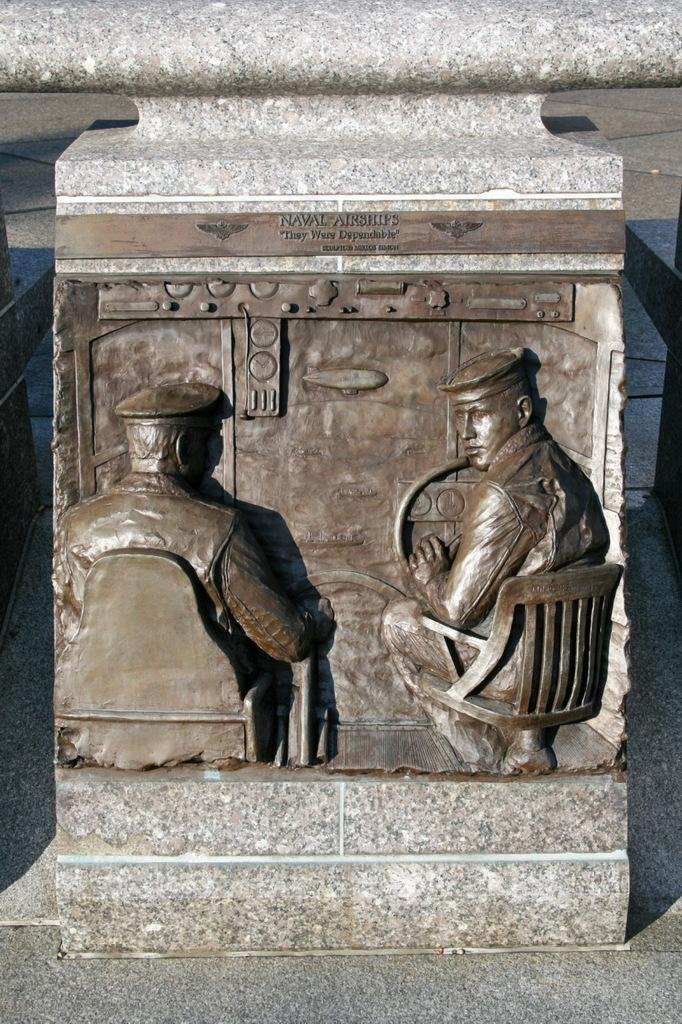What is the main object in the image? There is a stone in the image. What is on the stone? There is a sculpture on the stone. What does the sculpture depict? The sculpture depicts two men sitting on chairs. What is one of the men holding in the sculpture? One of the men is holding a steering wheel. Is there any text or writing on the sculpture? Yes, there is writing on the top of the sculpture. What type of leaf is falling from the tree in the image? There is no tree or leaf present in the image; it features a stone with a sculpture on it. How does the weather affect the two men sitting on chairs in the image? The weather is not mentioned in the image, so it cannot be determined how it affects the two men sitting on chairs. 